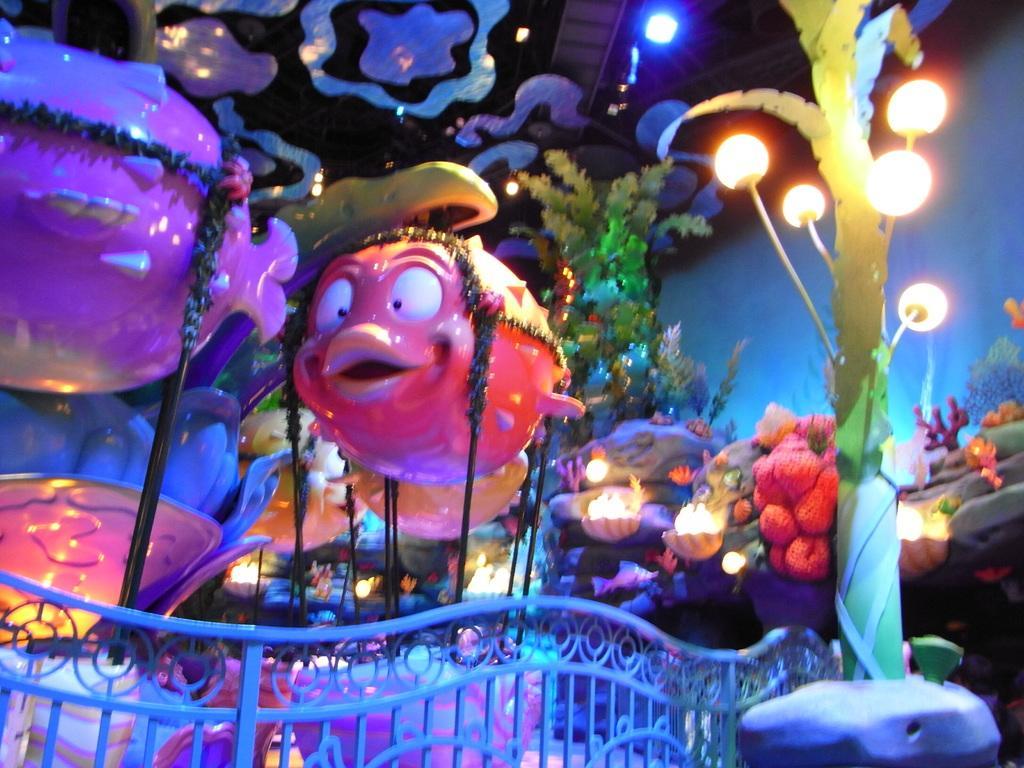Could you give a brief overview of what you see in this image? In this picture we can see ride, lights, pole, railing, plants and objects. 